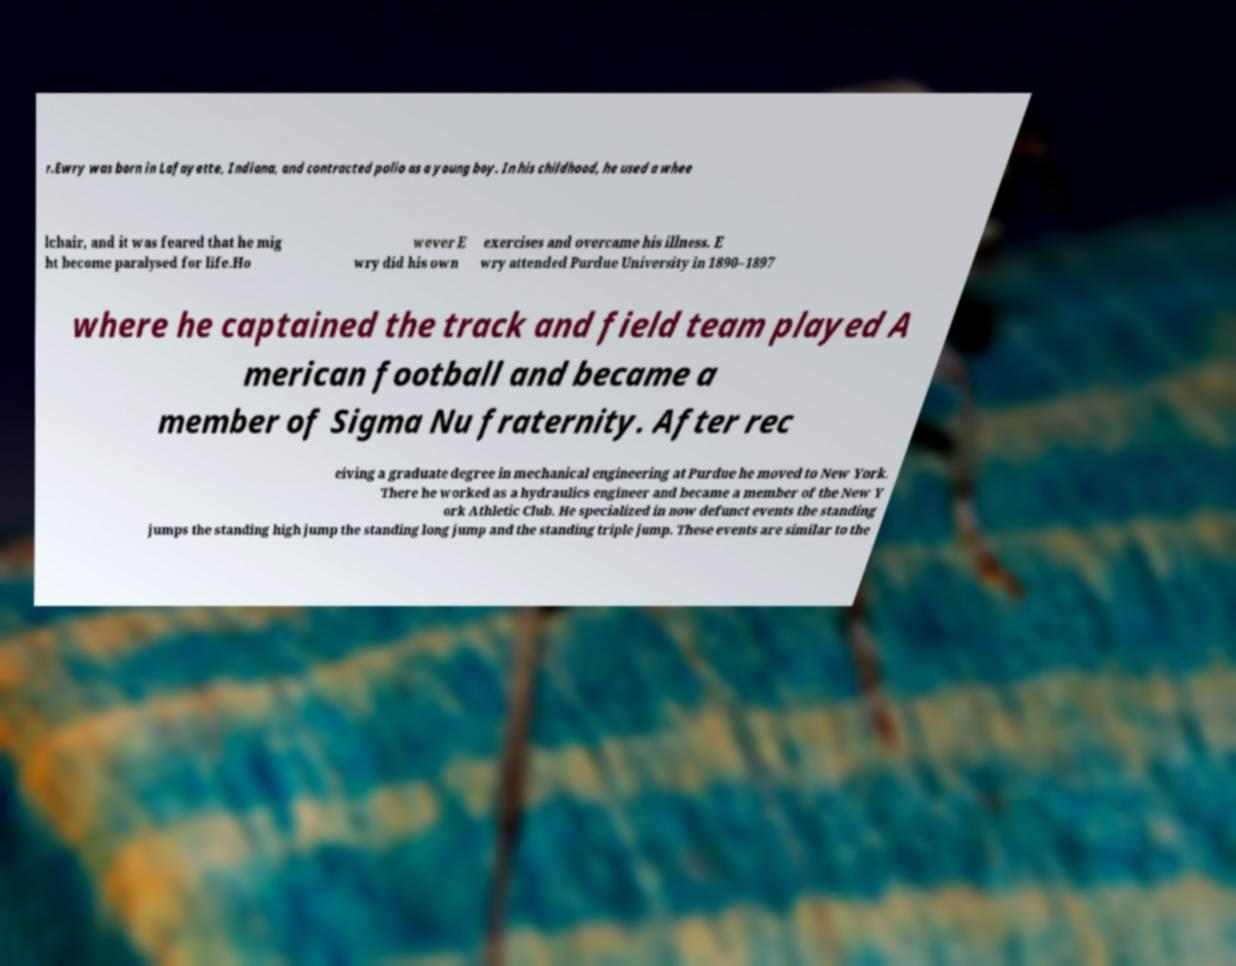Could you extract and type out the text from this image? r.Ewry was born in Lafayette, Indiana, and contracted polio as a young boy. In his childhood, he used a whee lchair, and it was feared that he mig ht become paralysed for life.Ho wever E wry did his own exercises and overcame his illness. E wry attended Purdue University in 1890–1897 where he captained the track and field team played A merican football and became a member of Sigma Nu fraternity. After rec eiving a graduate degree in mechanical engineering at Purdue he moved to New York. There he worked as a hydraulics engineer and became a member of the New Y ork Athletic Club. He specialized in now defunct events the standing jumps the standing high jump the standing long jump and the standing triple jump. These events are similar to the 